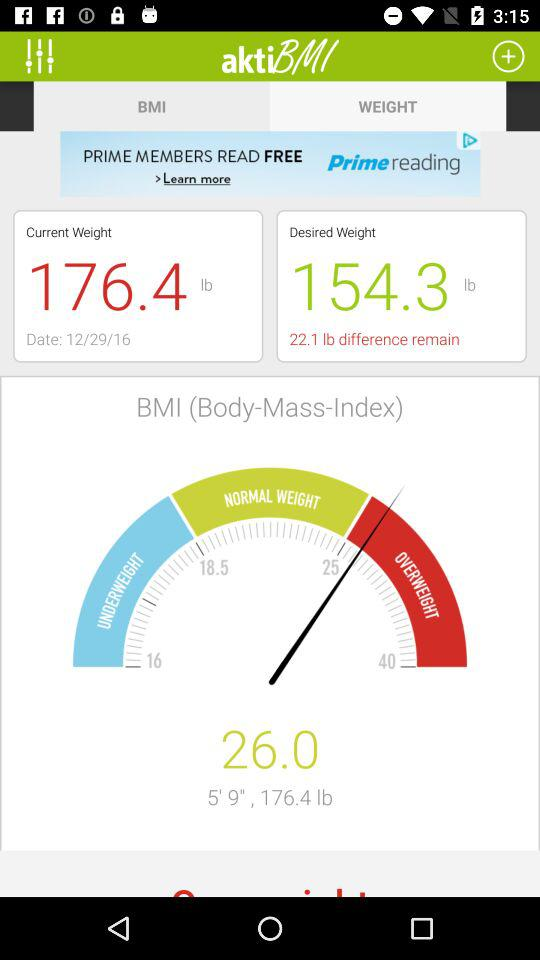What is the desired weight? The desired weight is 154.3 lbs. 